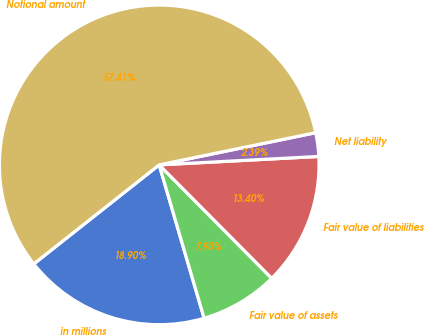Convert chart. <chart><loc_0><loc_0><loc_500><loc_500><pie_chart><fcel>in millions<fcel>Fair value of assets<fcel>Fair value of liabilities<fcel>Net liability<fcel>Notional amount<nl><fcel>18.9%<fcel>7.9%<fcel>13.4%<fcel>2.39%<fcel>57.41%<nl></chart> 